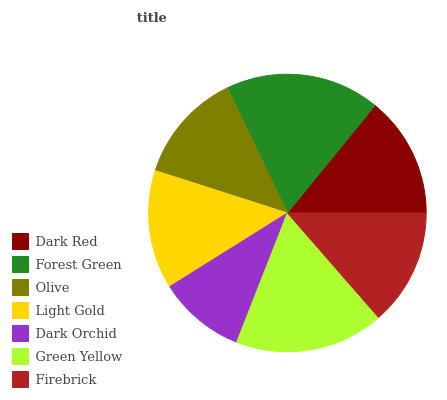Is Dark Orchid the minimum?
Answer yes or no. Yes. Is Forest Green the maximum?
Answer yes or no. Yes. Is Olive the minimum?
Answer yes or no. No. Is Olive the maximum?
Answer yes or no. No. Is Forest Green greater than Olive?
Answer yes or no. Yes. Is Olive less than Forest Green?
Answer yes or no. Yes. Is Olive greater than Forest Green?
Answer yes or no. No. Is Forest Green less than Olive?
Answer yes or no. No. Is Light Gold the high median?
Answer yes or no. Yes. Is Light Gold the low median?
Answer yes or no. Yes. Is Firebrick the high median?
Answer yes or no. No. Is Dark Red the low median?
Answer yes or no. No. 